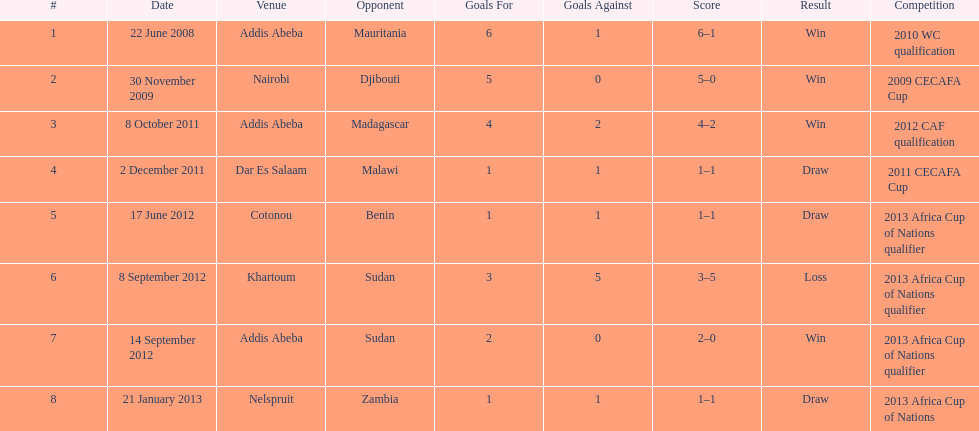Number of different teams listed on the chart 7. 